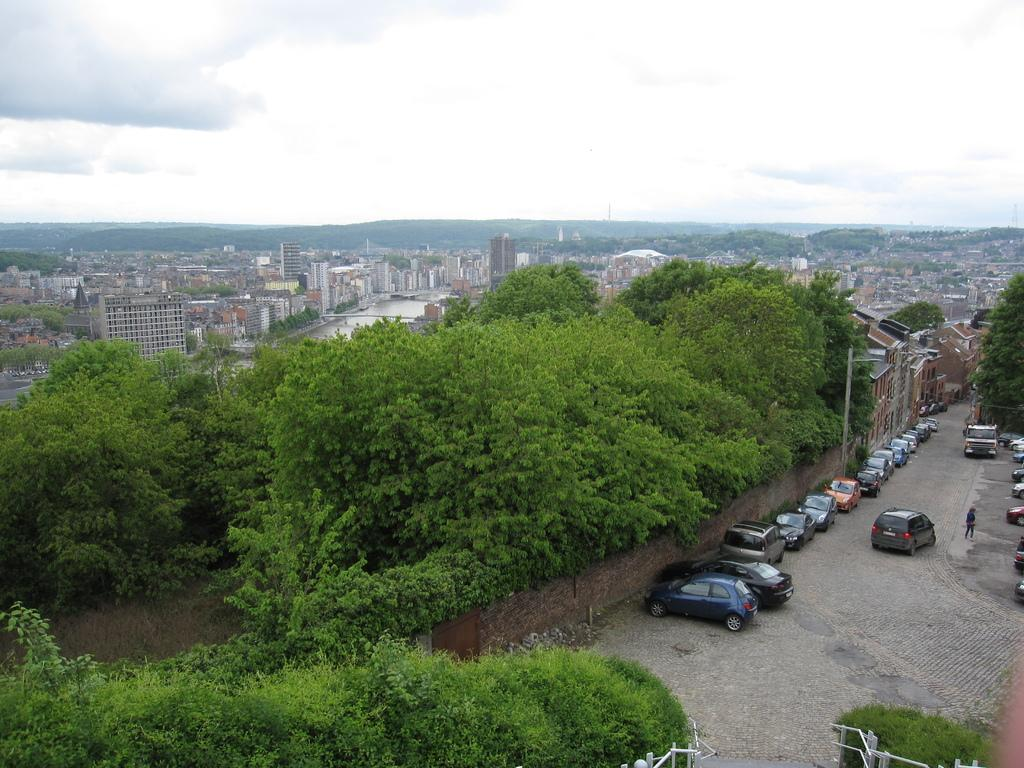What type of structures can be seen in the image? There are many buildings in the image. What other natural elements are present in the image? There are trees in the image. Can you describe the parking situation in the image? Vehicles are parked on the road near a wall. What type of landscape feature is visible in the image? Hills are visible in the image. What is visible in the sky in the image? The sky is visible with clouds. Where is the secret meeting taking place in the image? There is no indication of a meeting in the image. What type of jewel can be seen on the hill in the image? There are no jewels visible in the image; only buildings, trees, vehicles, hills, and clouds can be seen. 